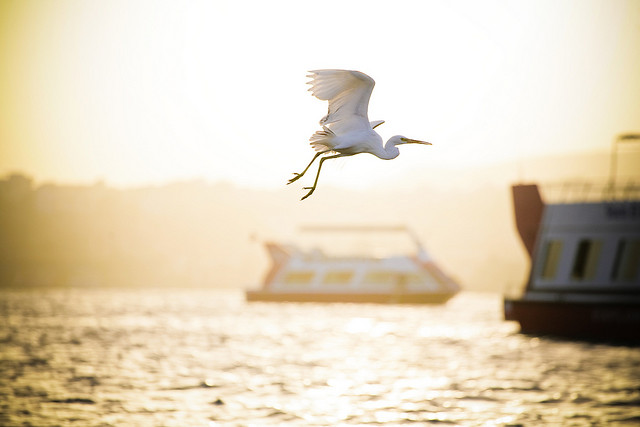What if the water was made of liquid gold? Describe that scenario. If the water in the image was made of liquid gold, it would shimmer brilliantly under the setting sun, casting a radiant glow that would light up the entire scene. The boats would appear to float majestically on this incredible golden expanse, their reflections creating a stunning visual spectacle. The bird flying above would seem almost otherworldly, its white feathers contrasting starkly against the golden backdrop. This surreal and magical transformation of the waterway would turn the scene into an ethereal landscape, a fantasy realm where the ordinary blends seamlessly with the extraordinary. 